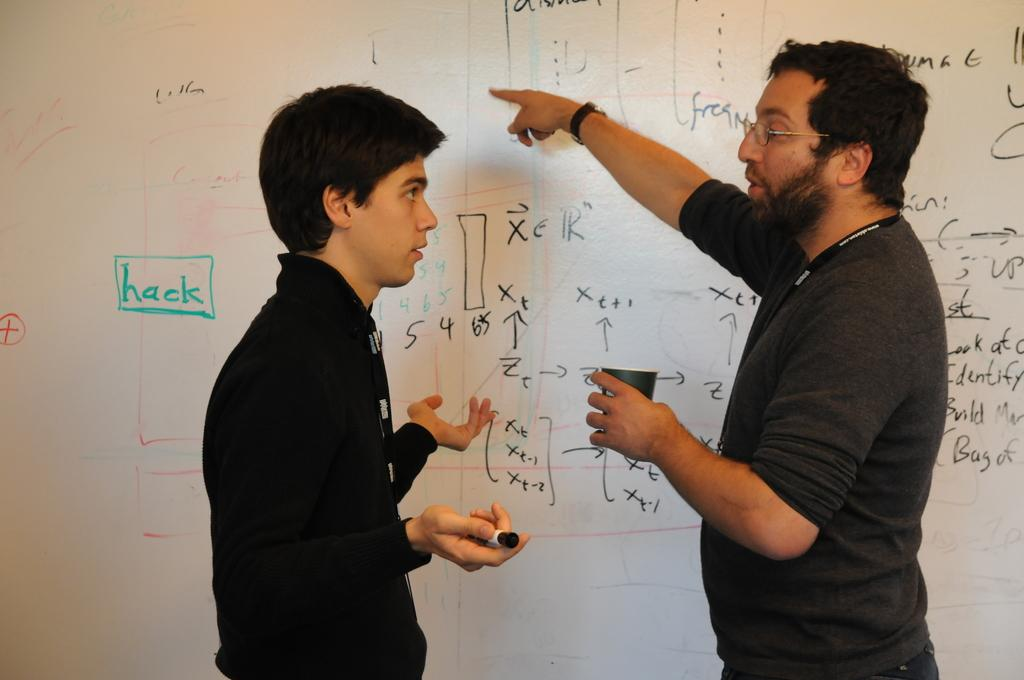<image>
Provide a brief description of the given image. Two people talking about diagrams including "hack" in front of a whiteboard. 